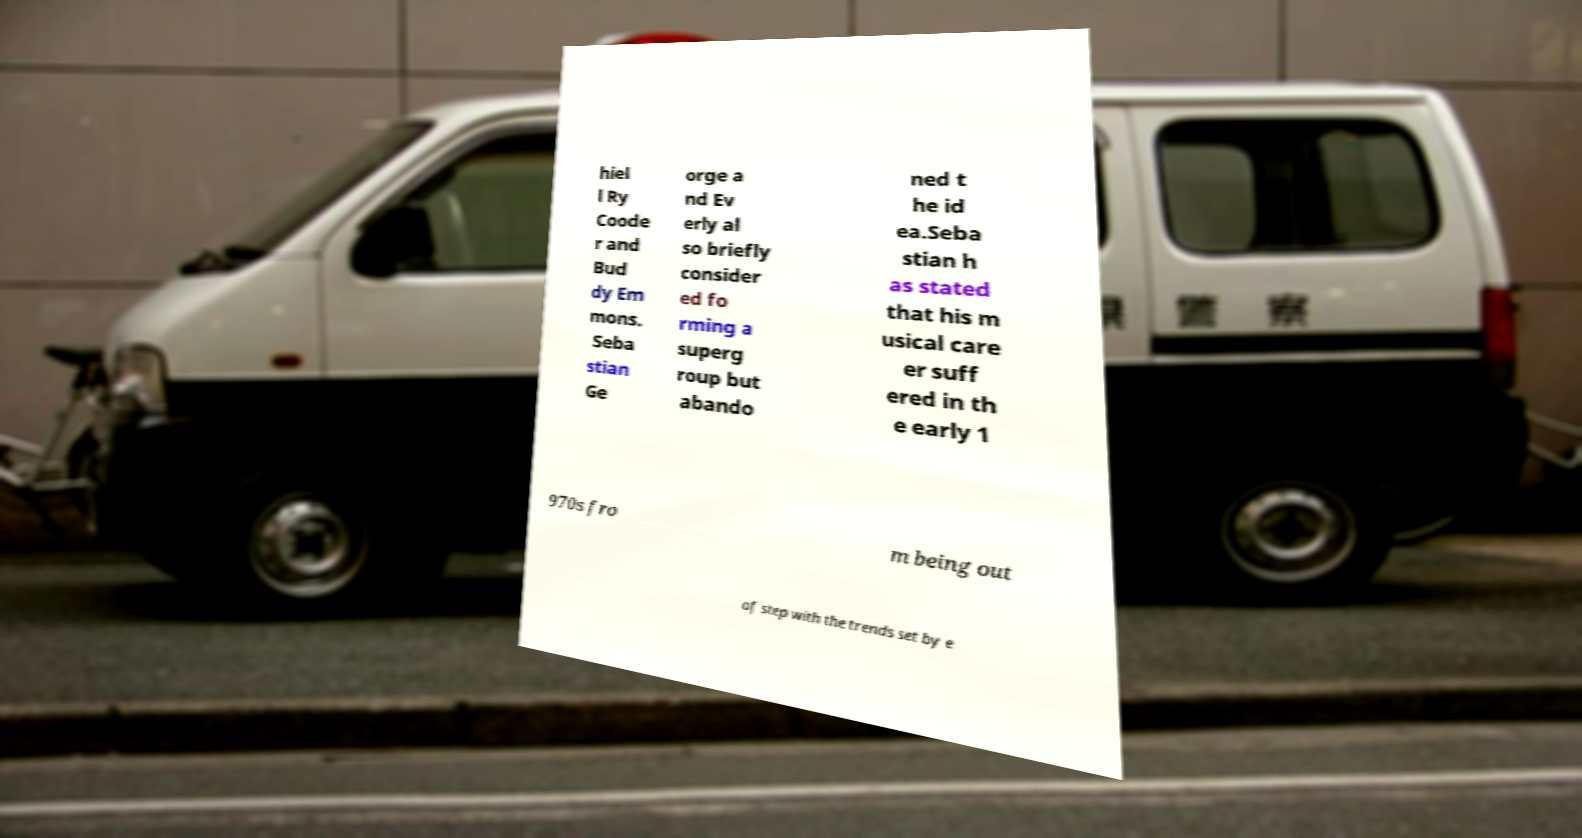Could you assist in decoding the text presented in this image and type it out clearly? hiel l Ry Coode r and Bud dy Em mons. Seba stian Ge orge a nd Ev erly al so briefly consider ed fo rming a superg roup but abando ned t he id ea.Seba stian h as stated that his m usical care er suff ered in th e early 1 970s fro m being out of step with the trends set by e 